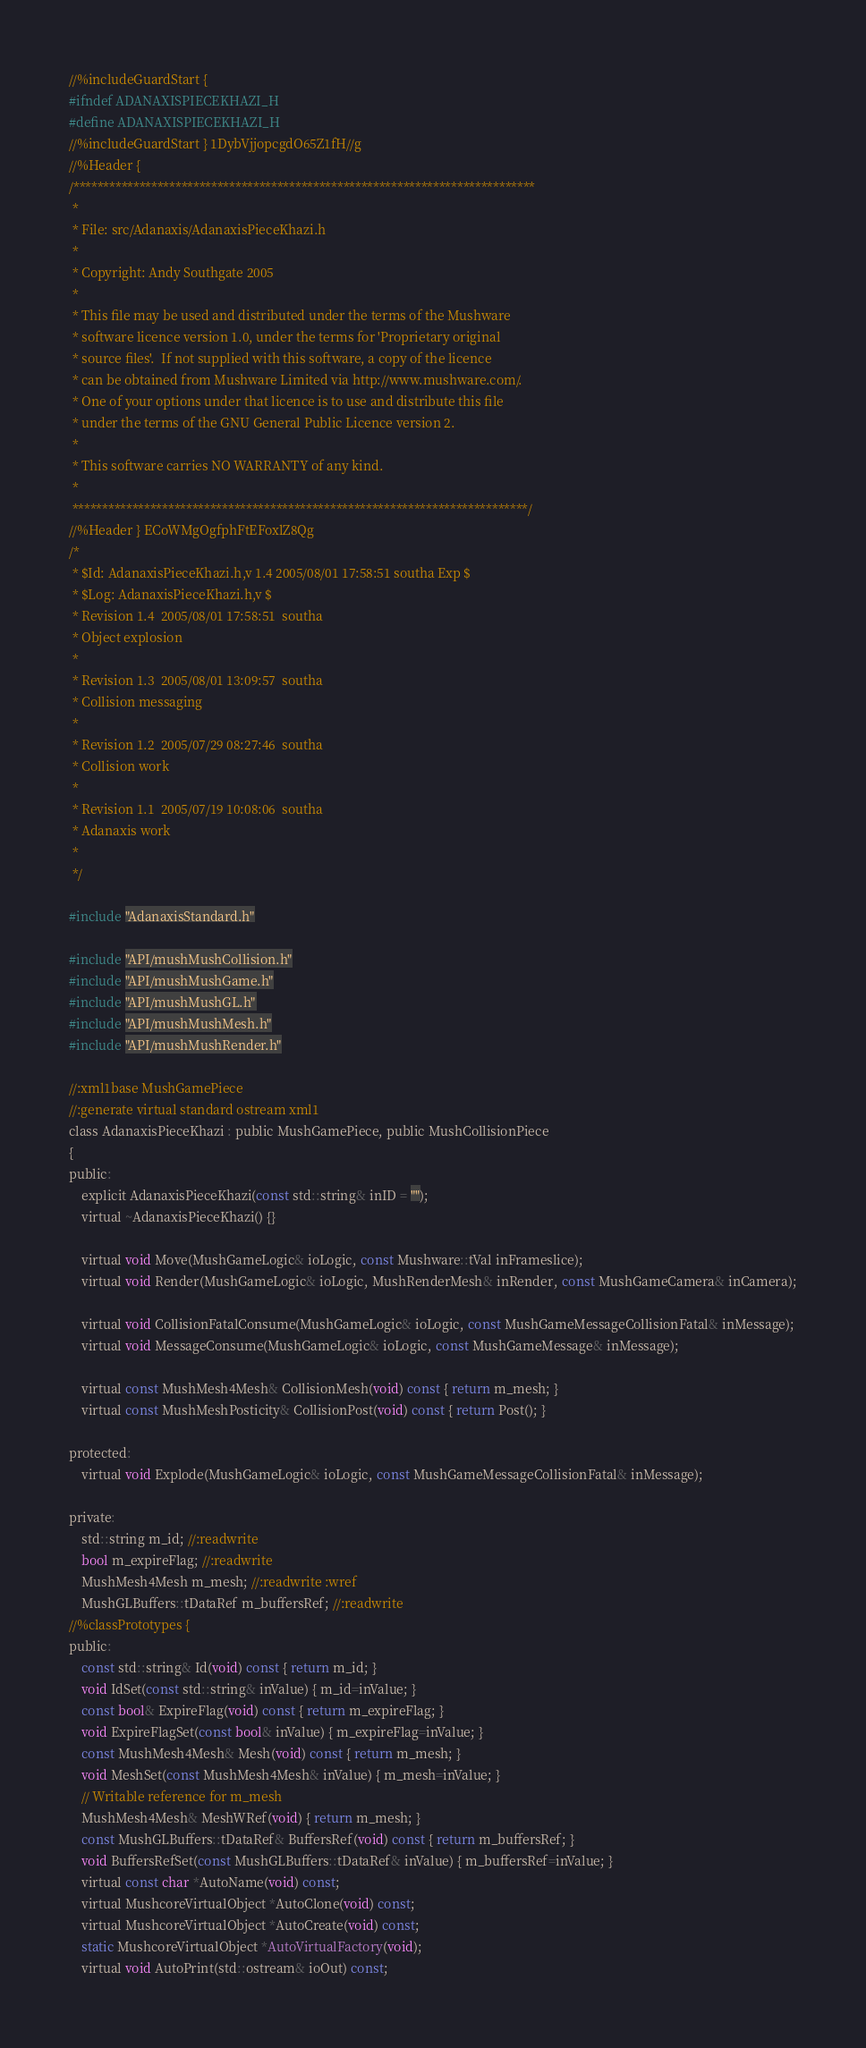Convert code to text. <code><loc_0><loc_0><loc_500><loc_500><_C_>//%includeGuardStart {
#ifndef ADANAXISPIECEKHAZI_H
#define ADANAXISPIECEKHAZI_H
//%includeGuardStart } 1DybVjjopcgdO65Z1fH//g
//%Header {
/*****************************************************************************
 *
 * File: src/Adanaxis/AdanaxisPieceKhazi.h
 *
 * Copyright: Andy Southgate 2005
 *
 * This file may be used and distributed under the terms of the Mushware
 * software licence version 1.0, under the terms for 'Proprietary original
 * source files'.  If not supplied with this software, a copy of the licence
 * can be obtained from Mushware Limited via http://www.mushware.com/.
 * One of your options under that licence is to use and distribute this file
 * under the terms of the GNU General Public Licence version 2.
 *
 * This software carries NO WARRANTY of any kind.
 *
 ****************************************************************************/
//%Header } ECoWMgOgfphFtEFoxlZ8Qg
/*
 * $Id: AdanaxisPieceKhazi.h,v 1.4 2005/08/01 17:58:51 southa Exp $
 * $Log: AdanaxisPieceKhazi.h,v $
 * Revision 1.4  2005/08/01 17:58:51  southa
 * Object explosion
 *
 * Revision 1.3  2005/08/01 13:09:57  southa
 * Collision messaging
 *
 * Revision 1.2  2005/07/29 08:27:46  southa
 * Collision work
 *
 * Revision 1.1  2005/07/19 10:08:06  southa
 * Adanaxis work
 *
 */

#include "AdanaxisStandard.h"

#include "API/mushMushCollision.h"
#include "API/mushMushGame.h"
#include "API/mushMushGL.h"
#include "API/mushMushMesh.h"
#include "API/mushMushRender.h"

//:xml1base MushGamePiece
//:generate virtual standard ostream xml1
class AdanaxisPieceKhazi : public MushGamePiece, public MushCollisionPiece
{
public:
    explicit AdanaxisPieceKhazi(const std::string& inID = "");
    virtual ~AdanaxisPieceKhazi() {}

    virtual void Move(MushGameLogic& ioLogic, const Mushware::tVal inFrameslice);
    virtual void Render(MushGameLogic& ioLogic, MushRenderMesh& inRender, const MushGameCamera& inCamera);
    
    virtual void CollisionFatalConsume(MushGameLogic& ioLogic, const MushGameMessageCollisionFatal& inMessage);
    virtual void MessageConsume(MushGameLogic& ioLogic, const MushGameMessage& inMessage);

    virtual const MushMesh4Mesh& CollisionMesh(void) const { return m_mesh; }
    virtual const MushMeshPosticity& CollisionPost(void) const { return Post(); }

protected:
    virtual void Explode(MushGameLogic& ioLogic, const MushGameMessageCollisionFatal& inMessage);
    
private:
    std::string m_id; //:readwrite
    bool m_expireFlag; //:readwrite
    MushMesh4Mesh m_mesh; //:readwrite :wref
    MushGLBuffers::tDataRef m_buffersRef; //:readwrite
//%classPrototypes {
public:
    const std::string& Id(void) const { return m_id; }
    void IdSet(const std::string& inValue) { m_id=inValue; }
    const bool& ExpireFlag(void) const { return m_expireFlag; }
    void ExpireFlagSet(const bool& inValue) { m_expireFlag=inValue; }
    const MushMesh4Mesh& Mesh(void) const { return m_mesh; }
    void MeshSet(const MushMesh4Mesh& inValue) { m_mesh=inValue; }
    // Writable reference for m_mesh
    MushMesh4Mesh& MeshWRef(void) { return m_mesh; }
    const MushGLBuffers::tDataRef& BuffersRef(void) const { return m_buffersRef; }
    void BuffersRefSet(const MushGLBuffers::tDataRef& inValue) { m_buffersRef=inValue; }
    virtual const char *AutoName(void) const;
    virtual MushcoreVirtualObject *AutoClone(void) const;
    virtual MushcoreVirtualObject *AutoCreate(void) const;
    static MushcoreVirtualObject *AutoVirtualFactory(void);
    virtual void AutoPrint(std::ostream& ioOut) const;</code> 